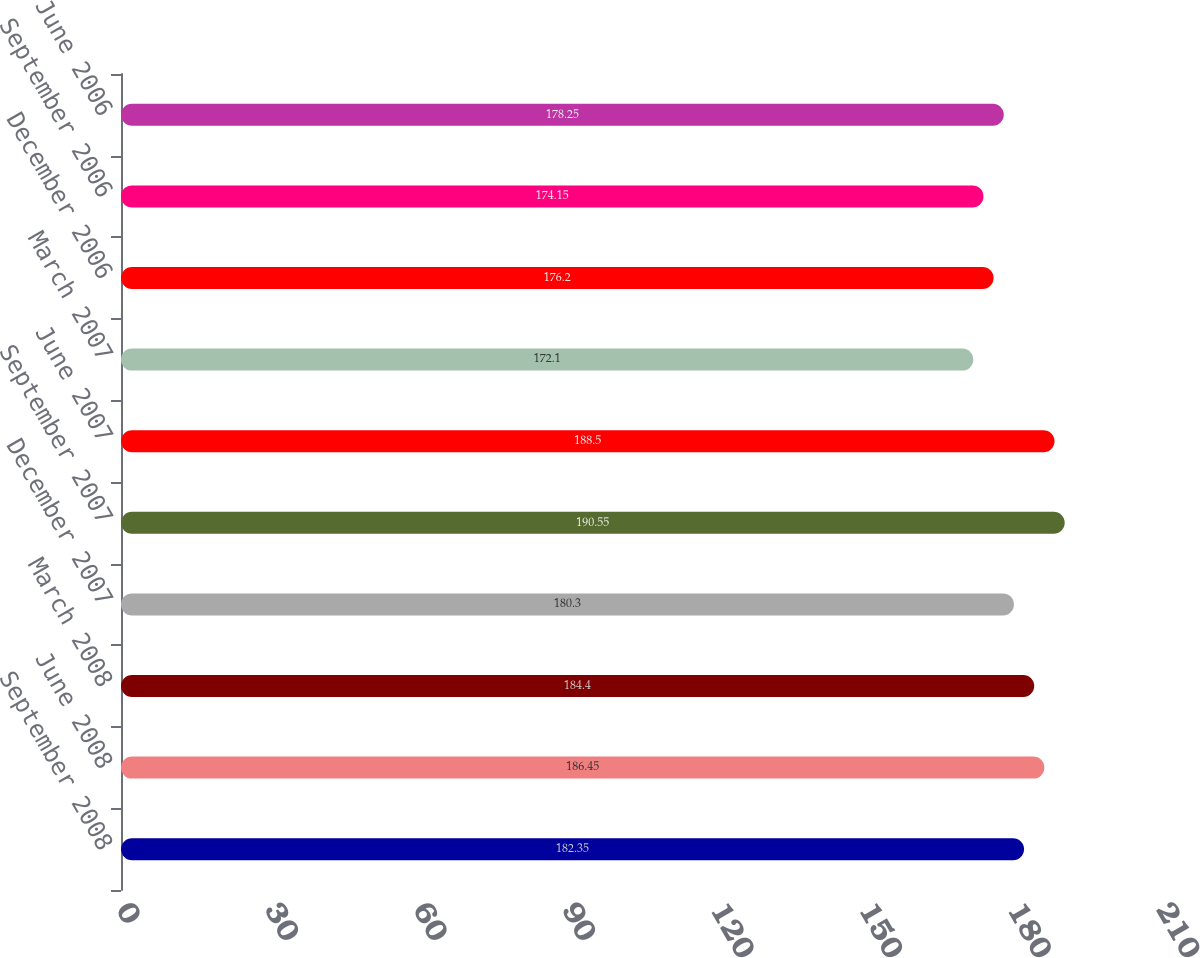<chart> <loc_0><loc_0><loc_500><loc_500><bar_chart><fcel>September 2008<fcel>June 2008<fcel>March 2008<fcel>December 2007<fcel>September 2007<fcel>June 2007<fcel>March 2007<fcel>December 2006<fcel>September 2006<fcel>June 2006<nl><fcel>182.35<fcel>186.45<fcel>184.4<fcel>180.3<fcel>190.55<fcel>188.5<fcel>172.1<fcel>176.2<fcel>174.15<fcel>178.25<nl></chart> 